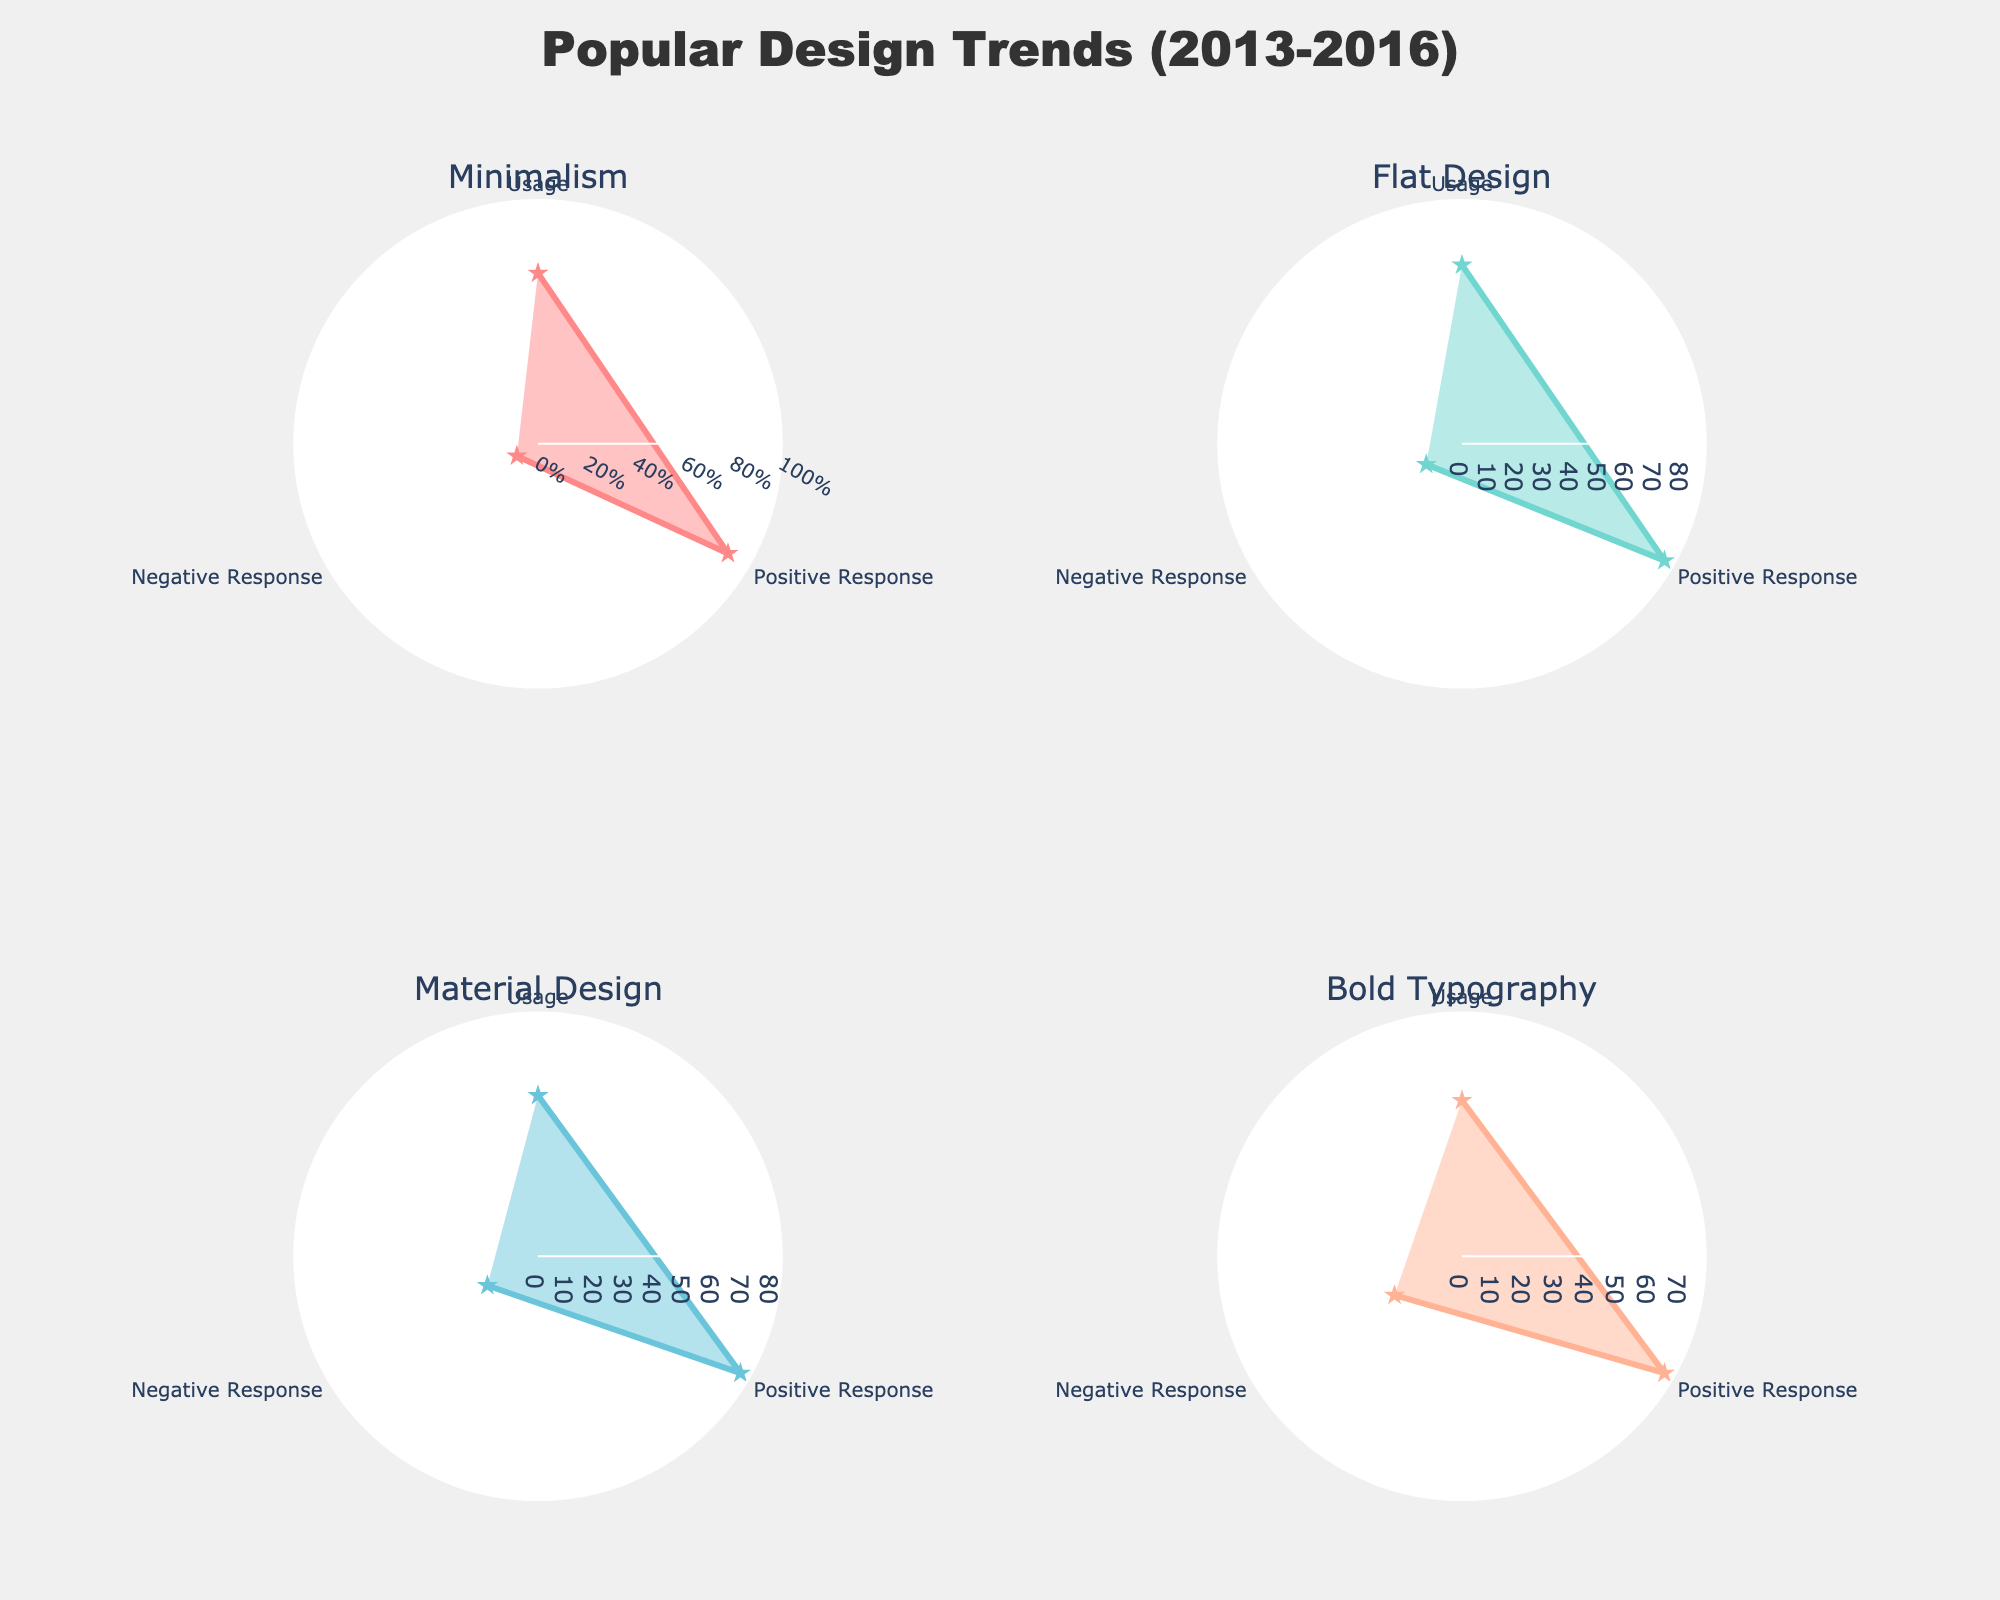What is the title of the chart? The title is located at the top of the figure and reads "Popular Design Trends (2013-2016)." It provides context for the data visualized in the subplots.
Answer: Popular Design Trends (2013-2016) How many design trends are shown in the subplots? By following the subplot titles, we can see that there are 4 design trends represented in the visualized plot.
Answer: 4 Which trend has the highest positive response rate? To determine this, compare the 'Positive Response' metrics for each trend in the plot. 'Minimalism' and 'Dark Mode' both have a positive response rate of 90%. So, these two trends tie for the highest rate.
Answer: Minimalism and Dark Mode What are the metrics represented in each subplot? Identify the axes labeling each subplot. The metrics are 'Usage,' 'Positive Response,' and 'Negative Response.'
Answer: Usage, Positive Response, Negative Response Which trend has the lowest usage percentage? Among all trends shown, 'Hand-Drawn Elements' has the lowest 'Usage' percentage, which is 40% as indicated on the corresponding subplot.
Answer: Hand-Drawn Elements Compare the 'Negative Response' between 'Minimalism' and 'Bold Typography'. Which one has a higher value? Examine the negative response values for both 'Minimalism' and 'Bold Typography.' 'Bold Typography' has a higher negative response of 25%, while 'Minimalism' has 10%.
Answer: Bold Typography Calculate the average 'Usage' percentage for 'Flat Design' and 'Material Design'. First, find the 'Usage' for both trends: 65% for 'Flat Design' and 55% for 'Material Design.' The average is (65 + 55)/2 = 60%.
Answer: 60% What is the difference between the 'Positive Response' rates of 'Asymmetrical Layouts' and 'Bold Typography'? The 'Positive Response' rate for 'Asymmetrical Layouts' is 80%, and for 'Bold Typography' is 75%. The difference is 80% - 75% = 5%.
Answer: 5% Which trend has the second highest 'Usage' percentage? By examining the 'Usage' percentages, 'Minimalism' tops at 70%, followed by 'Dark Mode' at 75%. So, the second-highest 'Usage' percentage is 70%.
Answer: Minimalism Is there a trend where the 'Positive Response' rate is less than 70%? All 'Positive Response' values should be checked for this condition. None of the trends in the given subplots fall below 70% in positive response.
Answer: No 